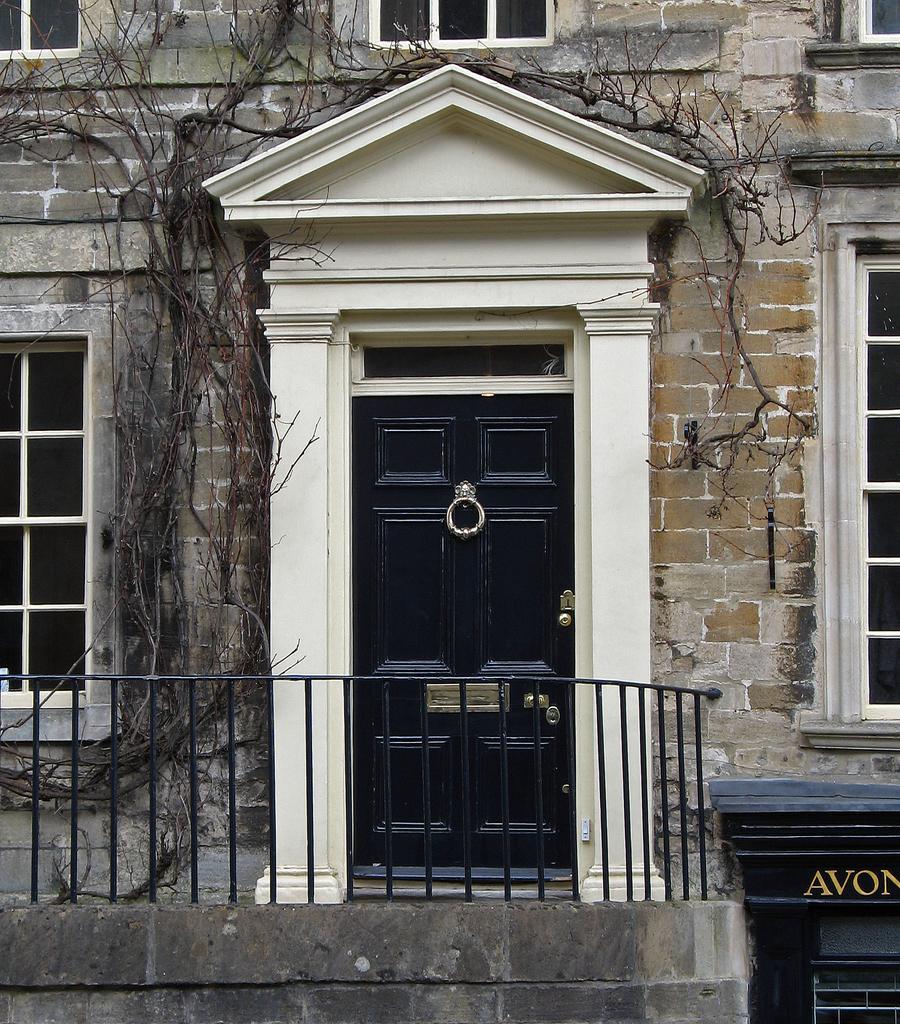Can you describe this image briefly? It is a zoomed in picture of the view of a building with the door, windows, railing and also the tree. 